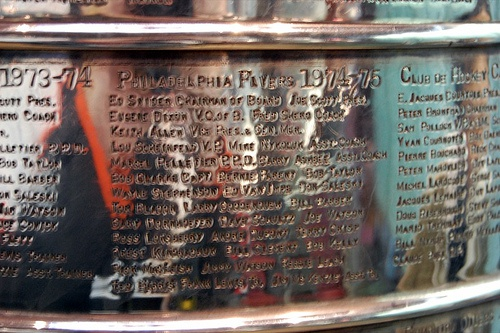Describe the objects in this image and their specific colors. I can see a vase in gray, black, and darkgray tones in this image. 